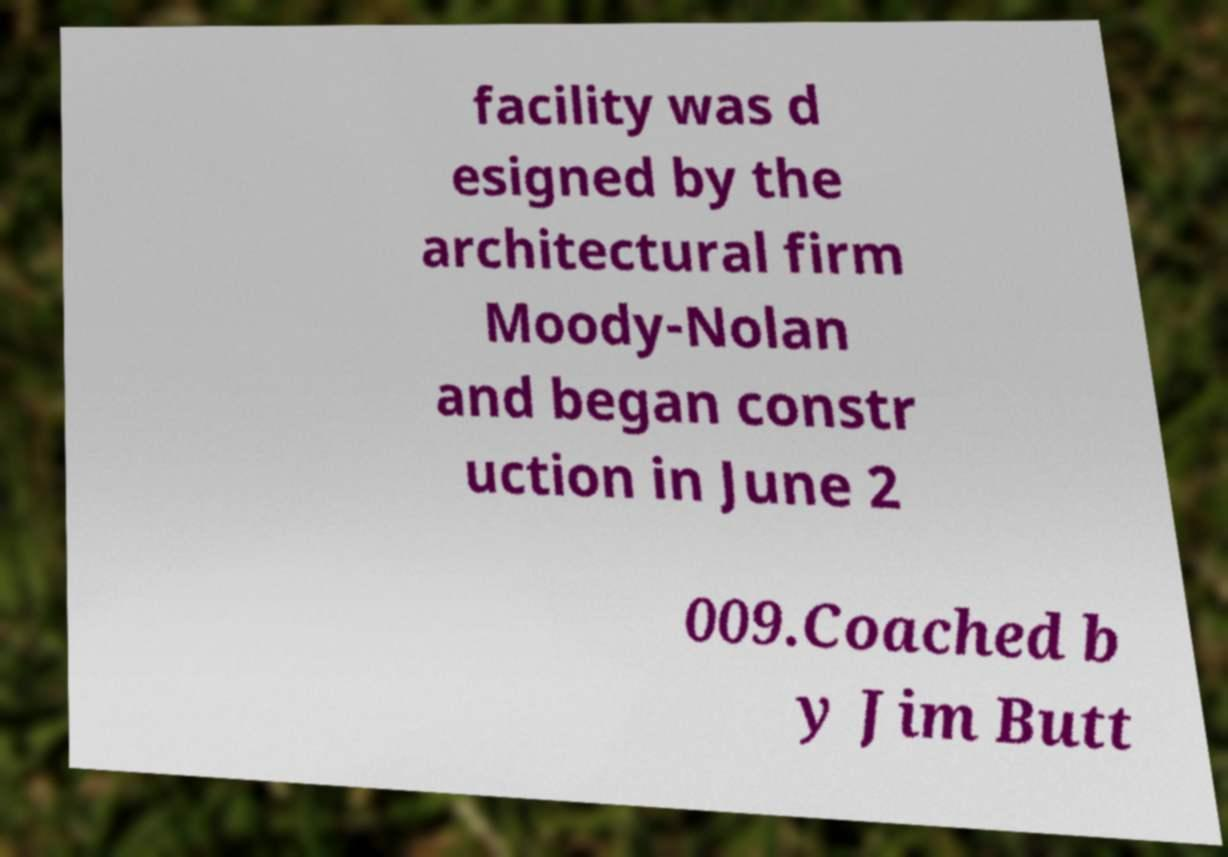Could you extract and type out the text from this image? facility was d esigned by the architectural firm Moody-Nolan and began constr uction in June 2 009.Coached b y Jim Butt 